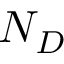<formula> <loc_0><loc_0><loc_500><loc_500>N _ { D }</formula> 